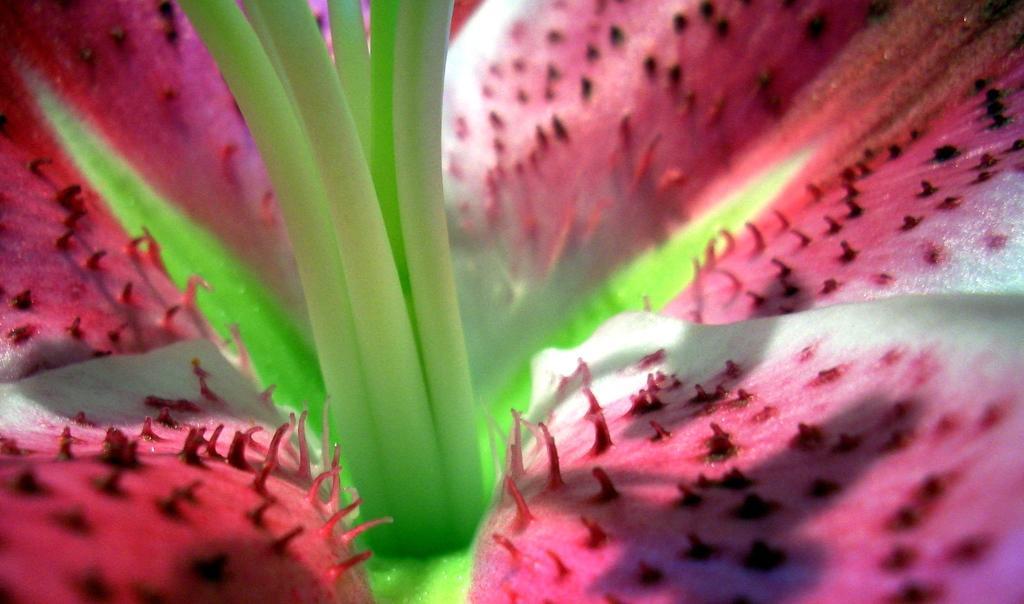How would you summarize this image in a sentence or two? In this image there is a flower having petals. 